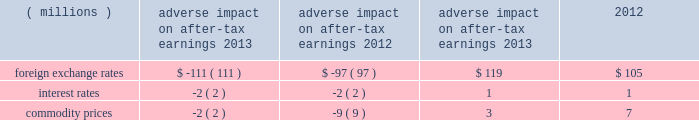Commodity prices risk : certain commodities the company uses in the production of its products are exposed to market price risks .
3m manages commodity price risks through negotiated supply contracts , price protection agreements and forward physical contracts .
The company uses commodity price swaps relative to natural gas as cash flow hedges of forecasted transactions to manage price volatility .
Generally , the length of time over which 3m hedges its exposure to the variability in future cash flows for its forecasted natural gas transactions is 12 months .
3m also enters into commodity price swaps that are not designated in hedge relationships to offset , in part , the impacts of fluctuations in costs associated with the use of certain precious metals .
The dollar equivalent gross notional amount of the company 2019s natural gas commodity price swaps designated as cash flow hedges and precious metal commodity price swaps not designated in hedge relationships were $ 19 million and $ 2 million , respectively , at december 31 , 2013 .
Value at risk : the value at risk analysis is performed annually .
A monte carlo simulation technique was used to test the company 2019s exposure to changes in currency rates , interest rates , and commodity prices and assess the risk of loss or benefit in after- tax earnings of financial instruments ( primarily debt ) , derivatives and underlying exposures outstanding at december 31 , 2013 .
The model ( third-party bank dataset ) used a 95 percent confidence level over a 12-month time horizon .
The exposure to changes in currency rates model used 18 currencies , interest rates related to four currencies , and commodity prices related to five commodities .
This model does not purport to represent what actually will be experienced by the company .
This model does not include certain hedge transactions , because the company believes their inclusion would not materially impact the results .
Foreign exchange rate risk of loss or benefit increased in 2013 , primarily due to increases in exposures , which is one of the key drivers in the valuation model .
Interest rate volatility remained stable in 2013 because interest rates are currently very low and are projected to remain low , based on forward rates .
The table summarizes the possible adverse and positive impacts to after-tax earnings related to these exposures .
Adverse impact on after-tax earnings positive impact on after-tax earnings .
In addition to the possible adverse and positive impacts discussed in the preceding table related to foreign exchange rates , recent historical information is as follows .
3m estimates that year-on-year currency effects , including hedging impacts , had the following effects on net income attributable to 3m : 2013 ( $ 74 million decrease ) and 2012 ( $ 103 million decrease ) .
This estimate includes the effect of translating profits from local currencies into u.s .
Dollars ; the impact of currency fluctuations on the transfer of goods between 3m operations in the united states and abroad ; and transaction gains and losses , including derivative instruments designed to reduce foreign currency exchange rate risks and the negative impact of swapping venezuelan bolivars into u.s .
Dollars .
3m estimates that year-on-year derivative and other transaction gains and losses had the following effects on net income attributable to 3m : 2013 ( $ 12 million decrease ) and 2012 ( $ 49 million increase ) .
An analysis of the global exposures related to purchased components and materials is performed at each year-end .
A one percent price change would result in a pre-tax cost or savings of approximately $ 76 million per year .
The global energy exposure is such that a 10 percent price change would result in a pre-tax cost or savings of approximately $ 45 million per .
\\nwhat was ratio of the estimates of the year-on-year derivative and other transaction gains and losses 2012 to 2013? 
Computations: (49 / 12)
Answer: 4.08333. 